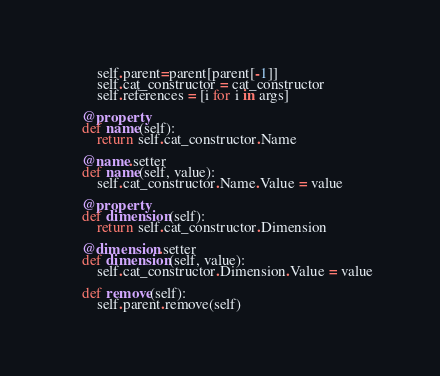Convert code to text. <code><loc_0><loc_0><loc_500><loc_500><_Python_>        self.parent=parent[parent[-1]]
        self.cat_constructor = cat_constructor
        self.references = [i for i in args]

    @property
    def name(self):
        return self.cat_constructor.Name

    @name.setter
    def name(self, value):
        self.cat_constructor.Name.Value = value

    @property
    def dimension(self):
        return self.cat_constructor.Dimension

    @dimension.setter
    def dimension(self, value):
        self.cat_constructor.Dimension.Value = value

    def remove(self):
        self.parent.remove(self)</code> 